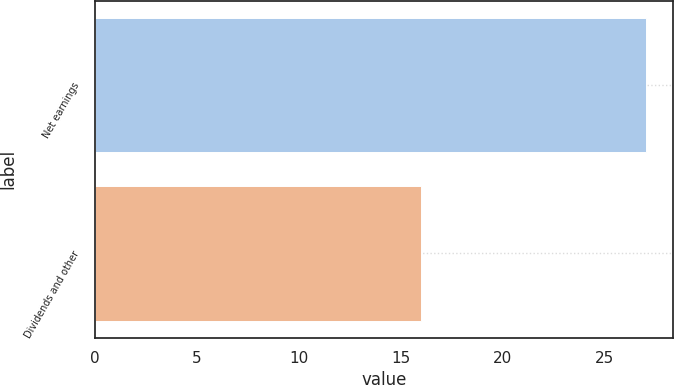<chart> <loc_0><loc_0><loc_500><loc_500><bar_chart><fcel>Net earnings<fcel>Dividends and other<nl><fcel>27<fcel>16<nl></chart> 